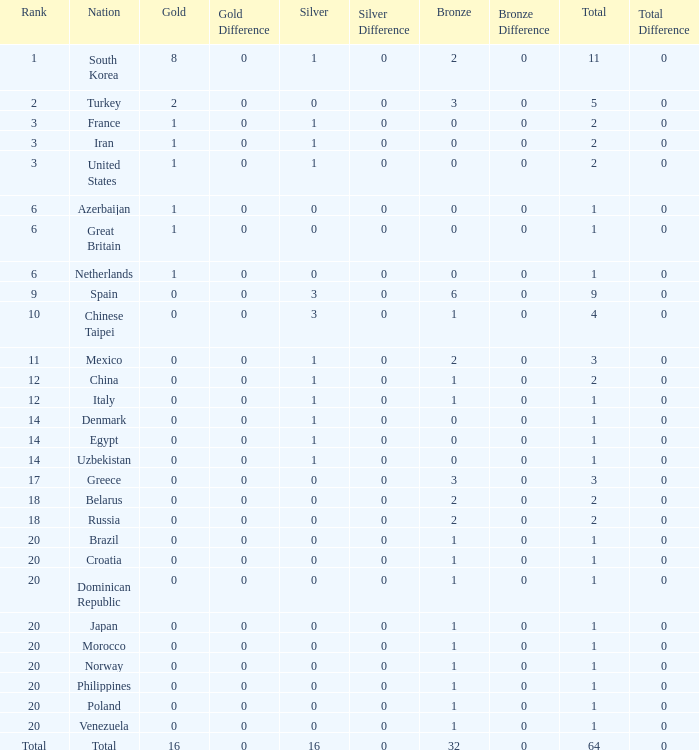What is the average number of bronze medals of the Philippines, which has more than 0 gold? None. 